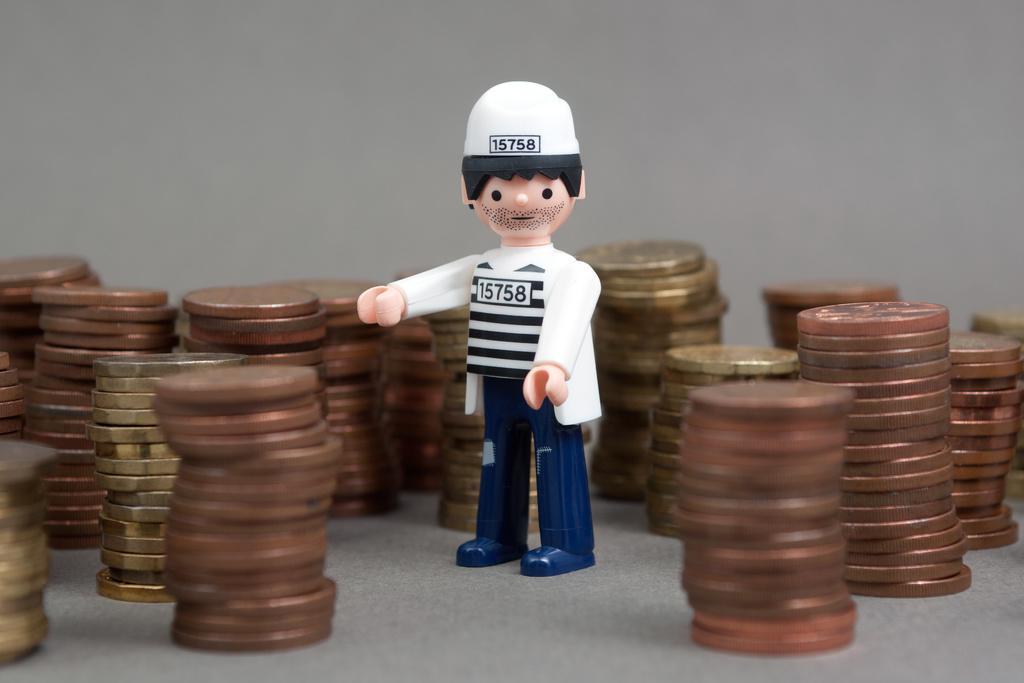Can you describe this image briefly? In this image there are coins in the middle there is a toy. 